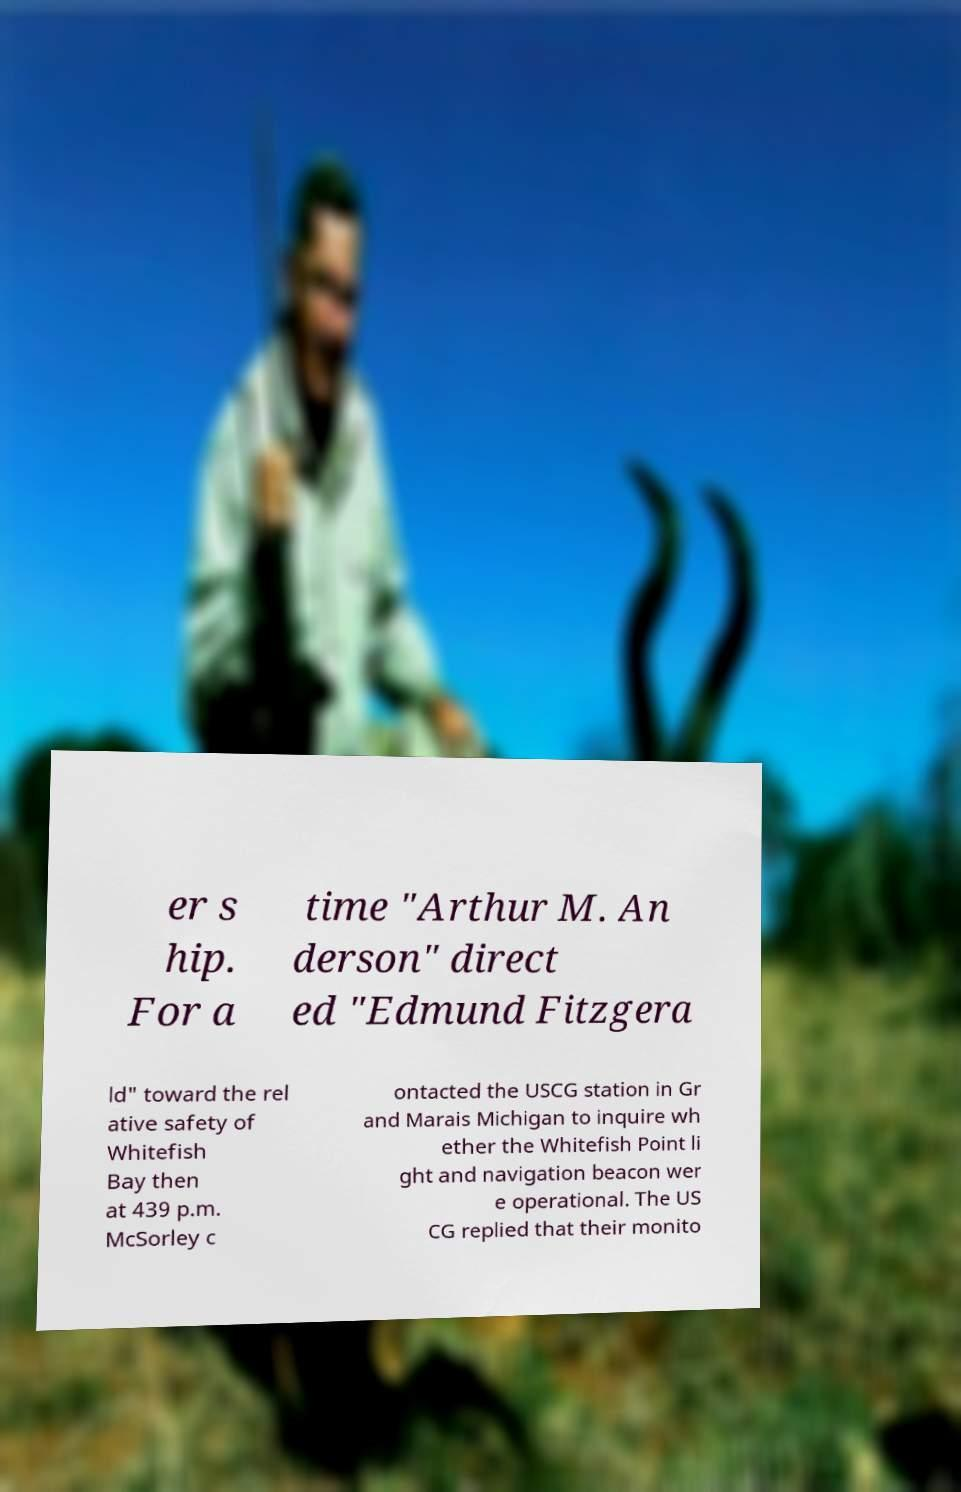Please identify and transcribe the text found in this image. er s hip. For a time "Arthur M. An derson" direct ed "Edmund Fitzgera ld" toward the rel ative safety of Whitefish Bay then at 439 p.m. McSorley c ontacted the USCG station in Gr and Marais Michigan to inquire wh ether the Whitefish Point li ght and navigation beacon wer e operational. The US CG replied that their monito 